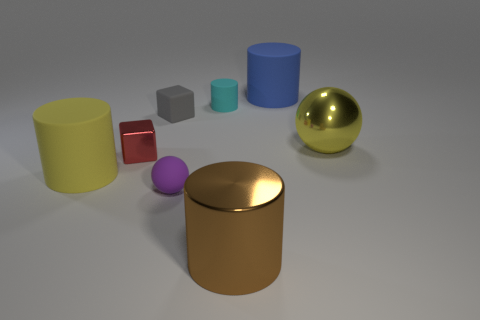Subtract all tiny cyan rubber cylinders. How many cylinders are left? 3 Subtract all blue cylinders. How many cylinders are left? 3 Subtract 1 cylinders. How many cylinders are left? 3 Subtract all spheres. How many objects are left? 6 Add 2 tiny blue matte blocks. How many objects exist? 10 Subtract all purple blocks. Subtract all cyan balls. How many blocks are left? 2 Subtract all small red shiny things. Subtract all small gray objects. How many objects are left? 6 Add 5 large yellow matte things. How many large yellow matte things are left? 6 Add 5 large things. How many large things exist? 9 Subtract 1 brown cylinders. How many objects are left? 7 